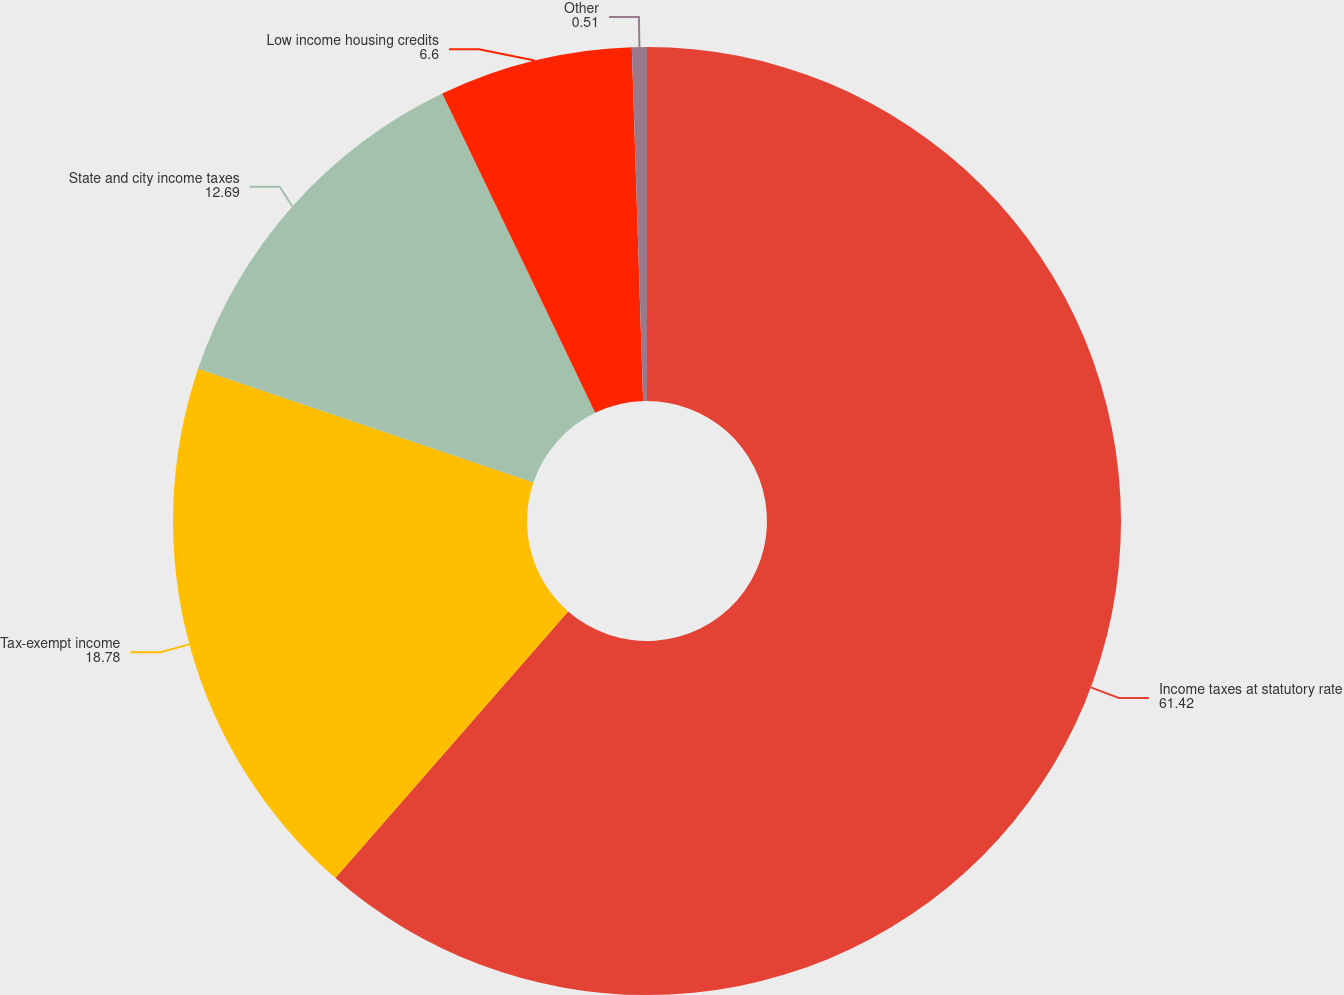<chart> <loc_0><loc_0><loc_500><loc_500><pie_chart><fcel>Income taxes at statutory rate<fcel>Tax-exempt income<fcel>State and city income taxes<fcel>Low income housing credits<fcel>Other<nl><fcel>61.42%<fcel>18.78%<fcel>12.69%<fcel>6.6%<fcel>0.51%<nl></chart> 